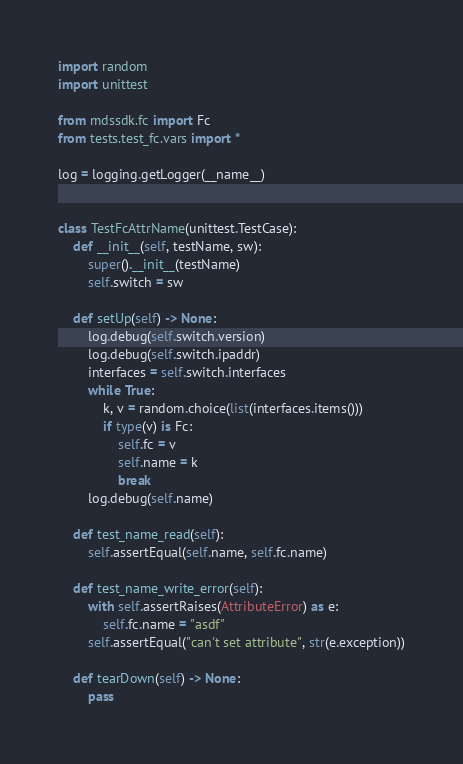<code> <loc_0><loc_0><loc_500><loc_500><_Python_>import random
import unittest

from mdssdk.fc import Fc
from tests.test_fc.vars import *

log = logging.getLogger(__name__)


class TestFcAttrName(unittest.TestCase):
    def __init__(self, testName, sw):
        super().__init__(testName)
        self.switch = sw

    def setUp(self) -> None:
        log.debug(self.switch.version)
        log.debug(self.switch.ipaddr)
        interfaces = self.switch.interfaces
        while True:
            k, v = random.choice(list(interfaces.items()))
            if type(v) is Fc:
                self.fc = v
                self.name = k
                break
        log.debug(self.name)

    def test_name_read(self):
        self.assertEqual(self.name, self.fc.name)

    def test_name_write_error(self):
        with self.assertRaises(AttributeError) as e:
            self.fc.name = "asdf"
        self.assertEqual("can't set attribute", str(e.exception))

    def tearDown(self) -> None:
        pass
</code> 